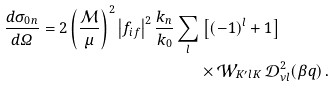<formula> <loc_0><loc_0><loc_500><loc_500>\frac { d \sigma _ { 0 n } } { d \varOmega } = 2 \left ( \frac { \mathcal { M } } { \mu } \right ) ^ { 2 } \left | f _ { i f } \right | ^ { 2 } \frac { k _ { n } } { k _ { 0 } } \sum _ { l } & \left [ ( - 1 ) ^ { l } + 1 \right ] \, \\ & \times \mathcal { W } _ { K ^ { \prime } l K } \, \mathcal { D } _ { \nu l } ^ { 2 } ( \beta q ) \, .</formula> 